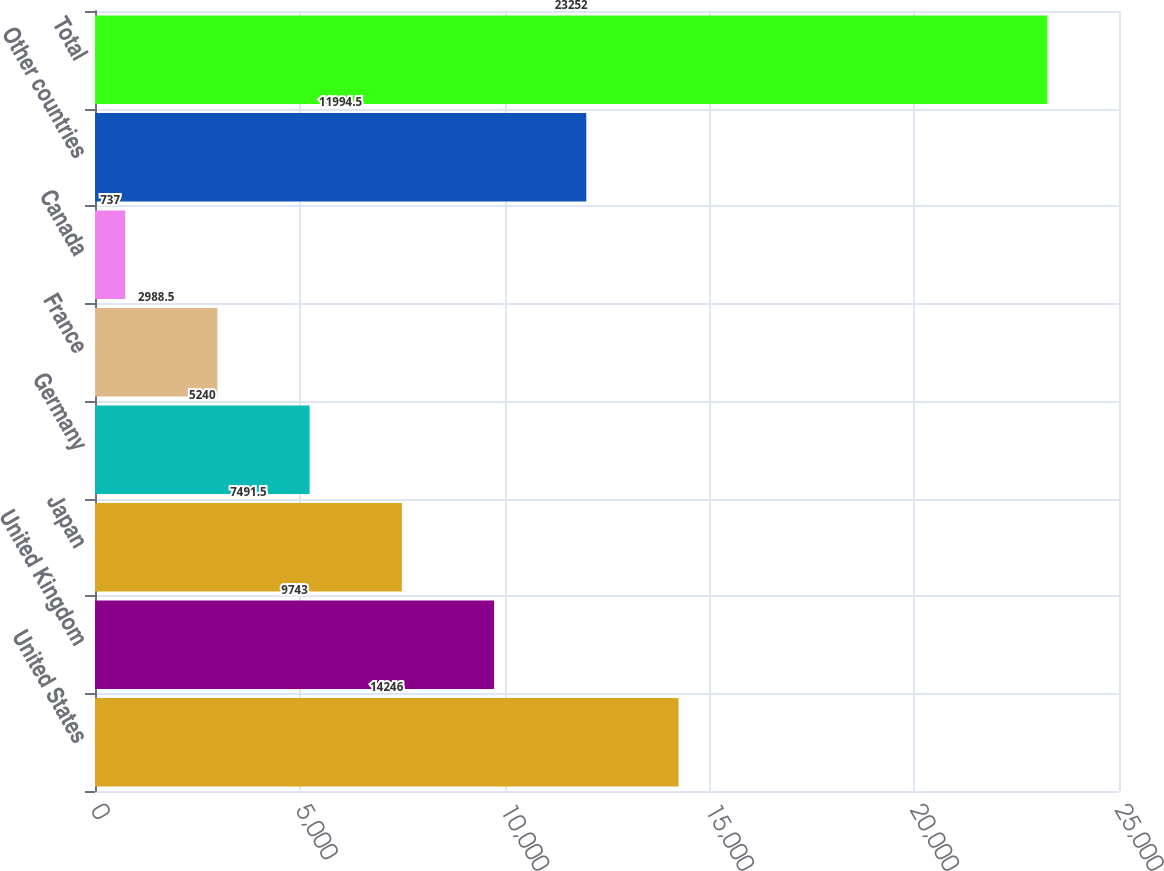Convert chart to OTSL. <chart><loc_0><loc_0><loc_500><loc_500><bar_chart><fcel>United States<fcel>United Kingdom<fcel>Japan<fcel>Germany<fcel>France<fcel>Canada<fcel>Other countries<fcel>Total<nl><fcel>14246<fcel>9743<fcel>7491.5<fcel>5240<fcel>2988.5<fcel>737<fcel>11994.5<fcel>23252<nl></chart> 